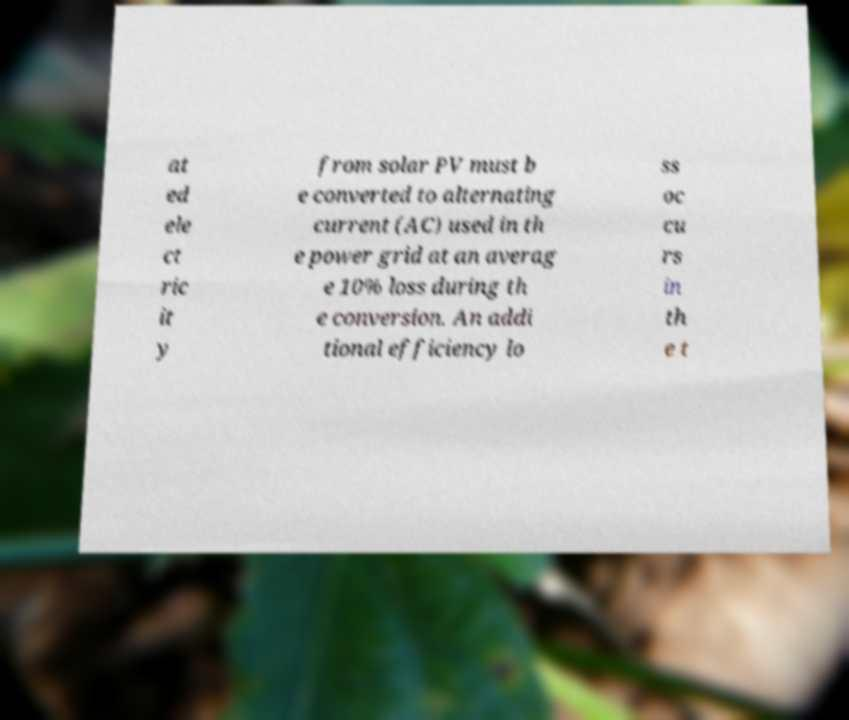Please read and relay the text visible in this image. What does it say? at ed ele ct ric it y from solar PV must b e converted to alternating current (AC) used in th e power grid at an averag e 10% loss during th e conversion. An addi tional efficiency lo ss oc cu rs in th e t 